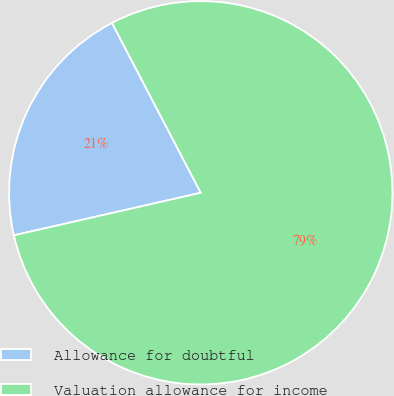Convert chart to OTSL. <chart><loc_0><loc_0><loc_500><loc_500><pie_chart><fcel>Allowance for doubtful<fcel>Valuation allowance for income<nl><fcel>20.9%<fcel>79.1%<nl></chart> 